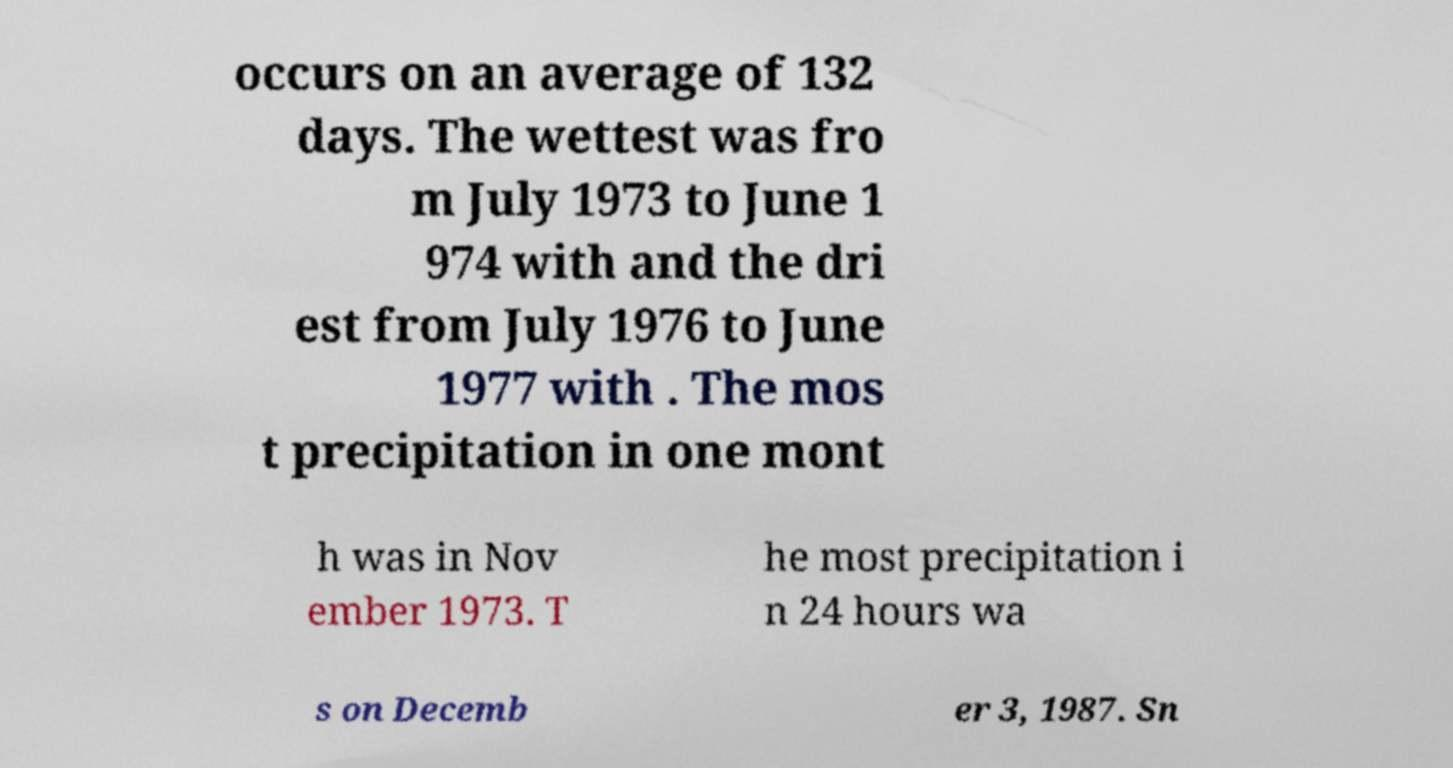Could you extract and type out the text from this image? occurs on an average of 132 days. The wettest was fro m July 1973 to June 1 974 with and the dri est from July 1976 to June 1977 with . The mos t precipitation in one mont h was in Nov ember 1973. T he most precipitation i n 24 hours wa s on Decemb er 3, 1987. Sn 